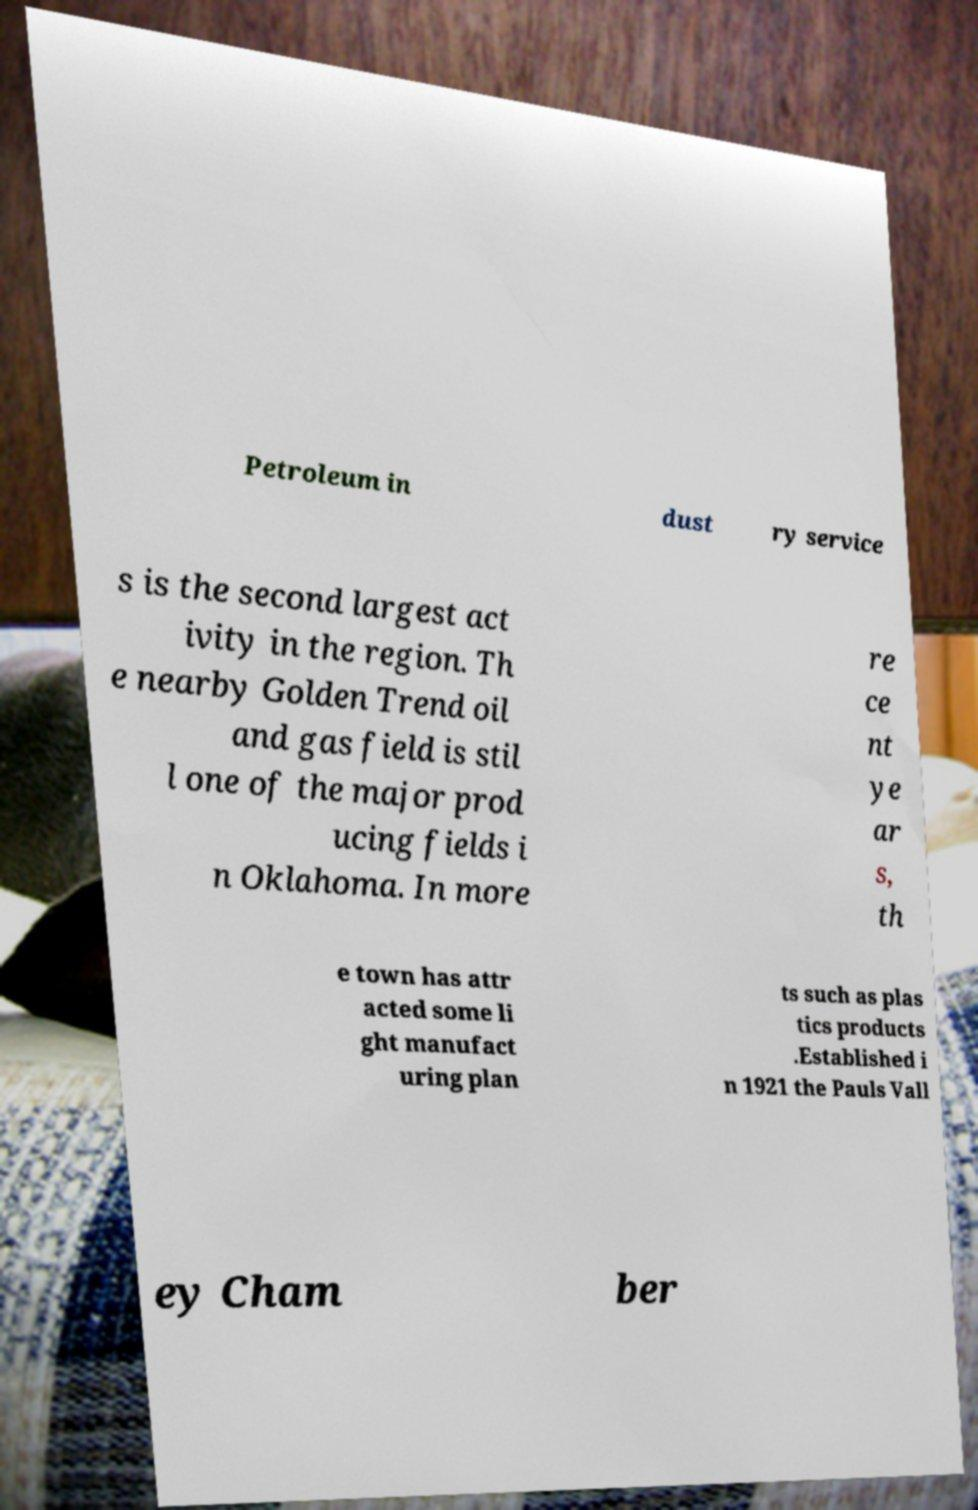For documentation purposes, I need the text within this image transcribed. Could you provide that? Petroleum in dust ry service s is the second largest act ivity in the region. Th e nearby Golden Trend oil and gas field is stil l one of the major prod ucing fields i n Oklahoma. In more re ce nt ye ar s, th e town has attr acted some li ght manufact uring plan ts such as plas tics products .Established i n 1921 the Pauls Vall ey Cham ber 